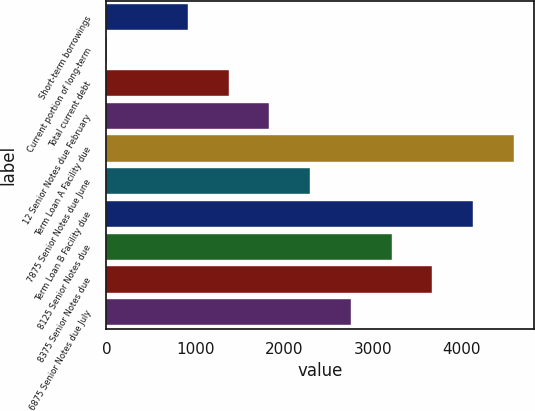Convert chart to OTSL. <chart><loc_0><loc_0><loc_500><loc_500><bar_chart><fcel>Short-term borrowings<fcel>Current portion of long-term<fcel>Total current debt<fcel>12 Senior Notes due February<fcel>Term Loan A Facility due<fcel>7875 Senior Notes due June<fcel>Term Loan B Facility due<fcel>8125 Senior Notes due<fcel>8375 Senior Notes due<fcel>6875 Senior Notes due July<nl><fcel>917.8<fcel>1.8<fcel>1375.8<fcel>1833.8<fcel>4581.8<fcel>2291.8<fcel>4123.8<fcel>3207.8<fcel>3665.8<fcel>2749.8<nl></chart> 